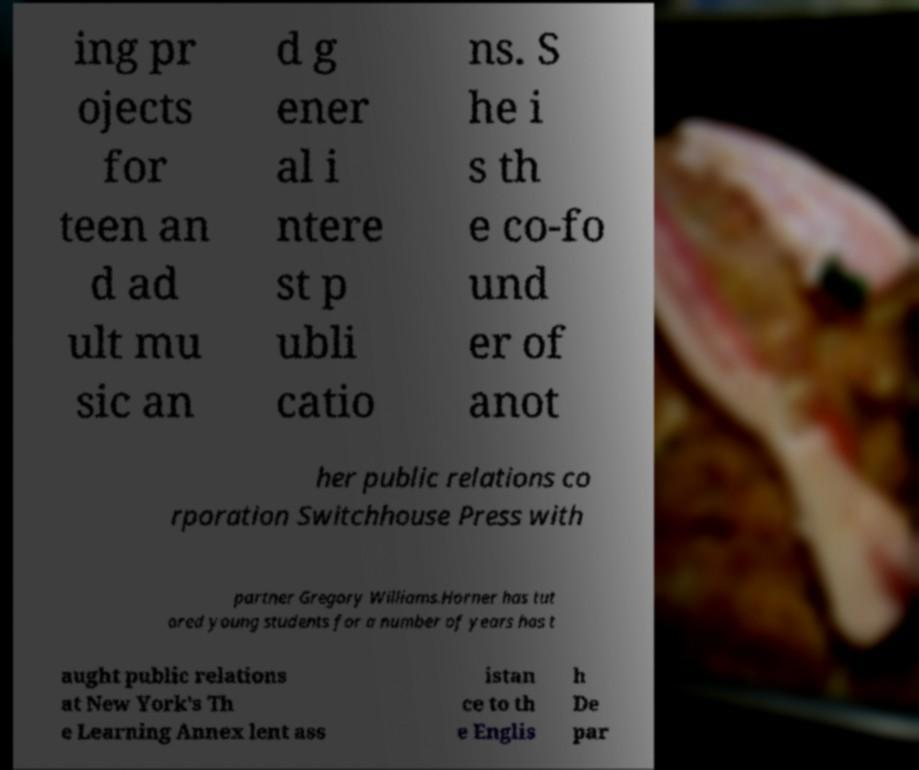Can you read and provide the text displayed in the image?This photo seems to have some interesting text. Can you extract and type it out for me? ing pr ojects for teen an d ad ult mu sic an d g ener al i ntere st p ubli catio ns. S he i s th e co-fo und er of anot her public relations co rporation Switchhouse Press with partner Gregory Williams.Horner has tut ored young students for a number of years has t aught public relations at New York's Th e Learning Annex lent ass istan ce to th e Englis h De par 